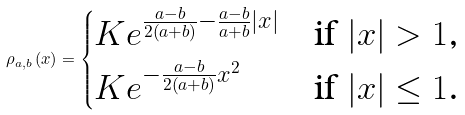Convert formula to latex. <formula><loc_0><loc_0><loc_500><loc_500>\rho _ { a , b } \left ( x \right ) = \begin{cases} K e ^ { \frac { a - b } { 2 \left ( a + b \right ) } - \frac { a - b } { a + b } | x | } & \text {if $|x| > 1$,} \\ K e ^ { - \frac { a - b } { 2 \left ( a + b \right ) } x ^ { 2 } } & \text {if $|x| \leq 1$.} \end{cases}</formula> 